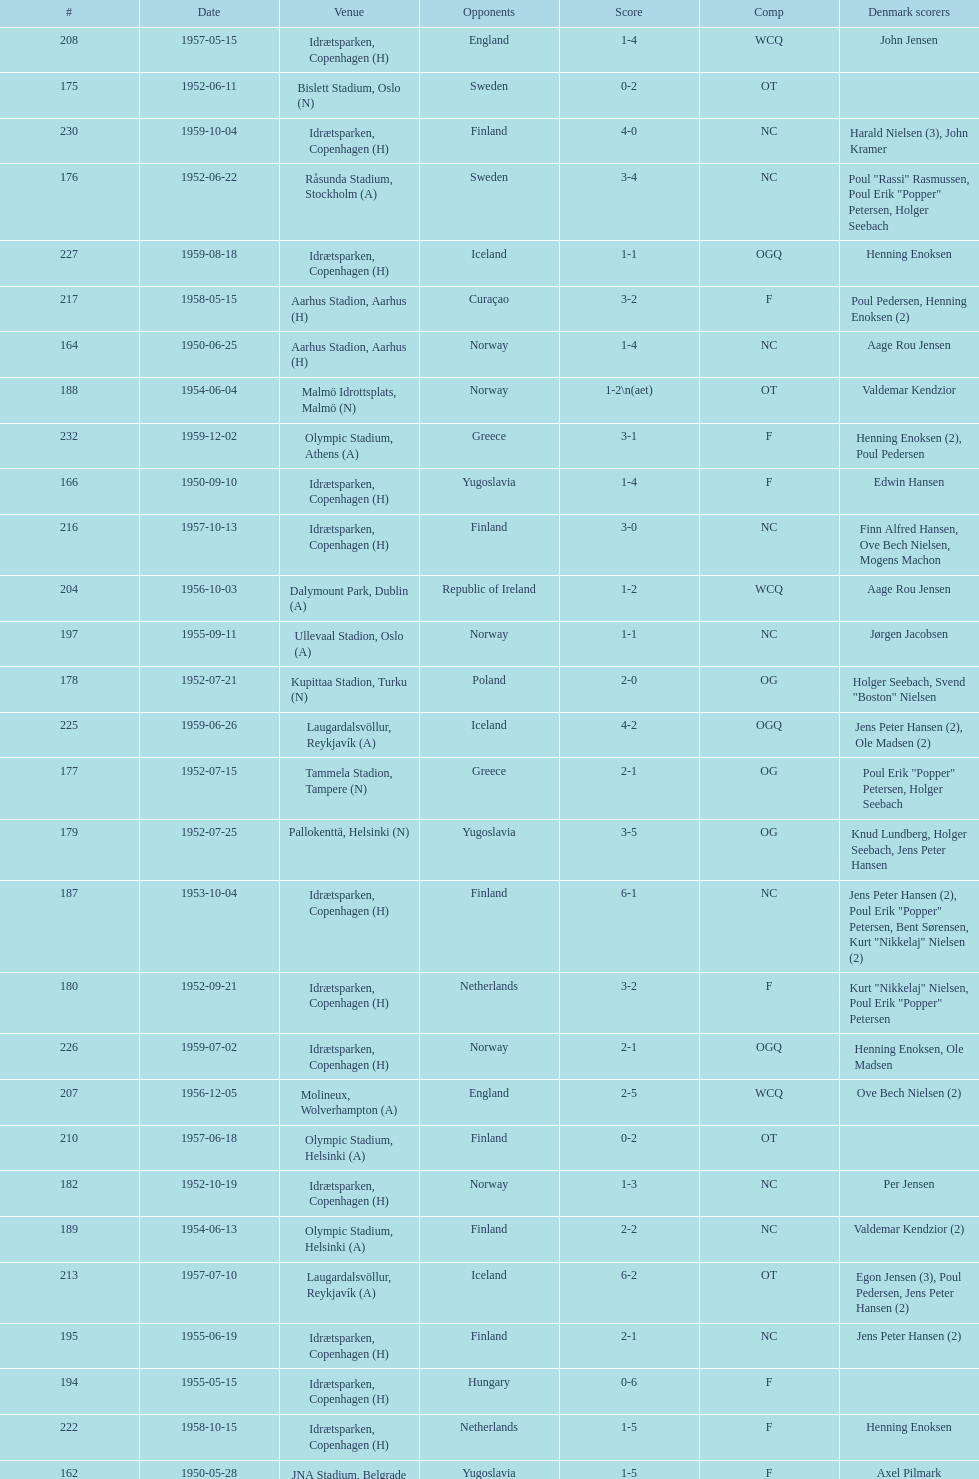How many times was poland the opponent? 2. 